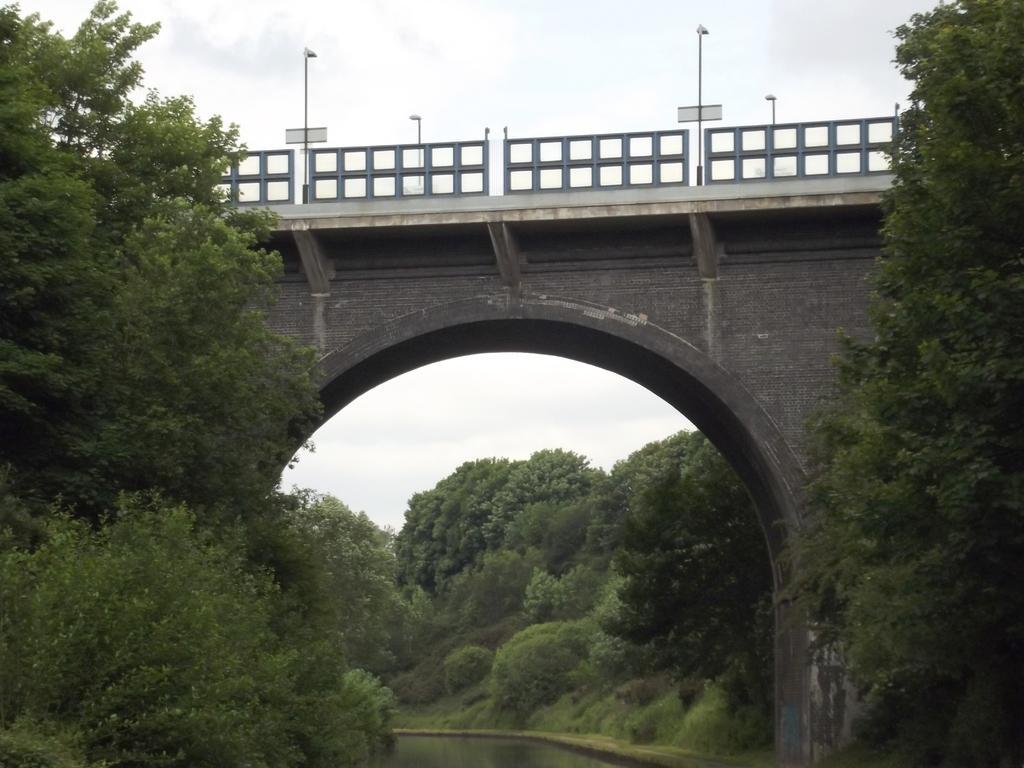How would you summarize this image in a sentence or two? In this image we can see a bridge with railings, light poles. Also there is an arch. On the sides there are trees. At the bottom there is water. In the background there is sky. 